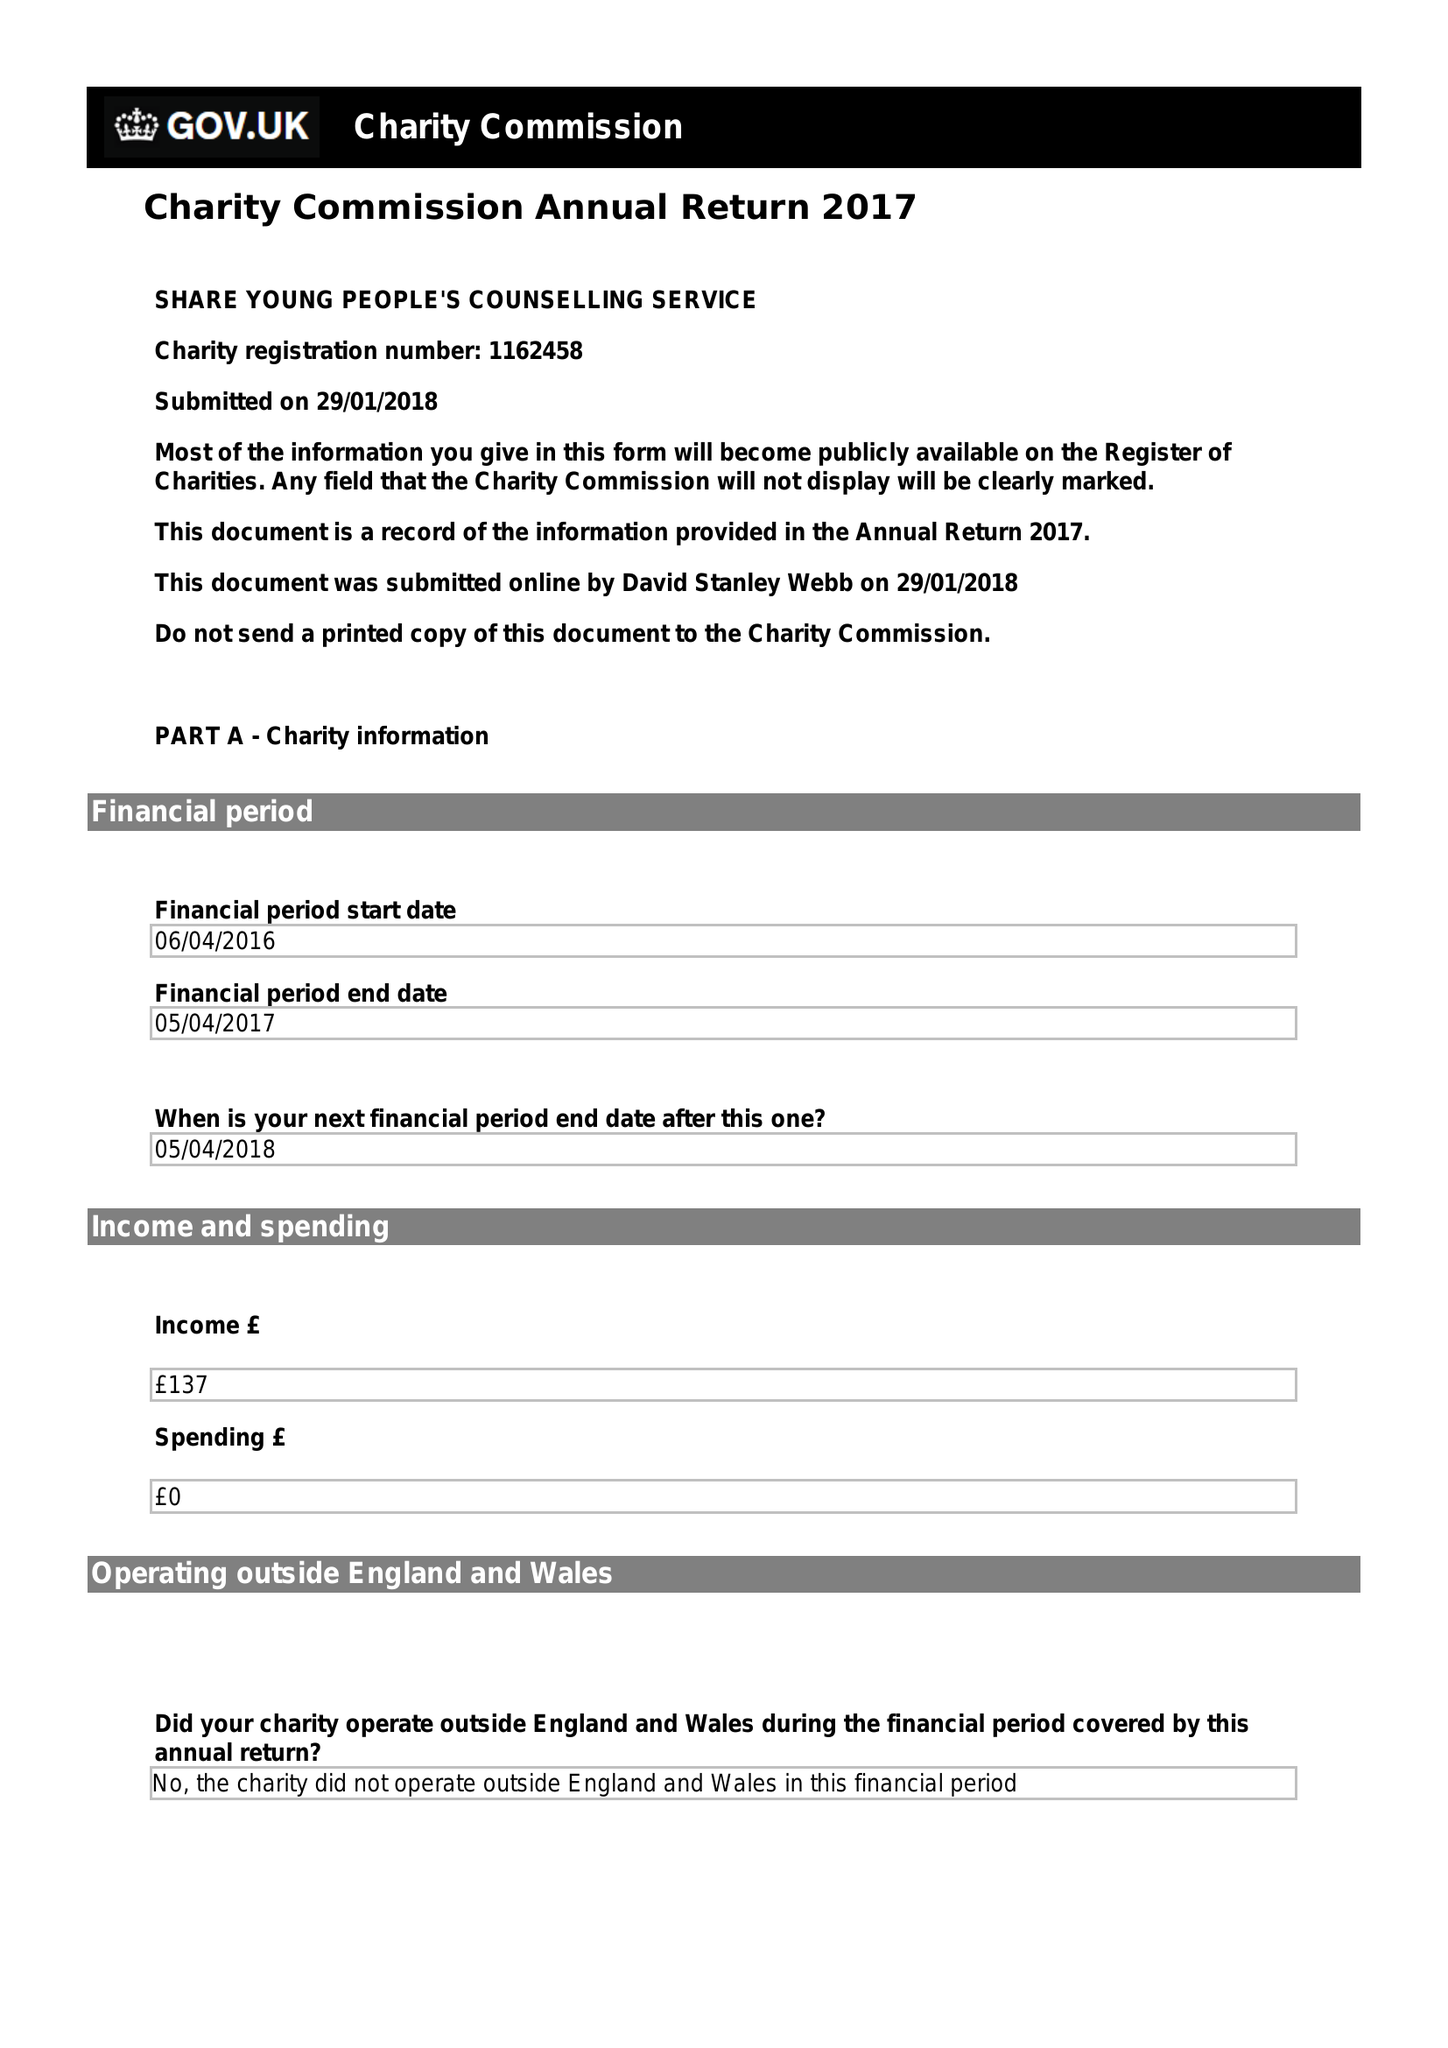What is the value for the charity_name?
Answer the question using a single word or phrase. Share Young People's Counselling Service 